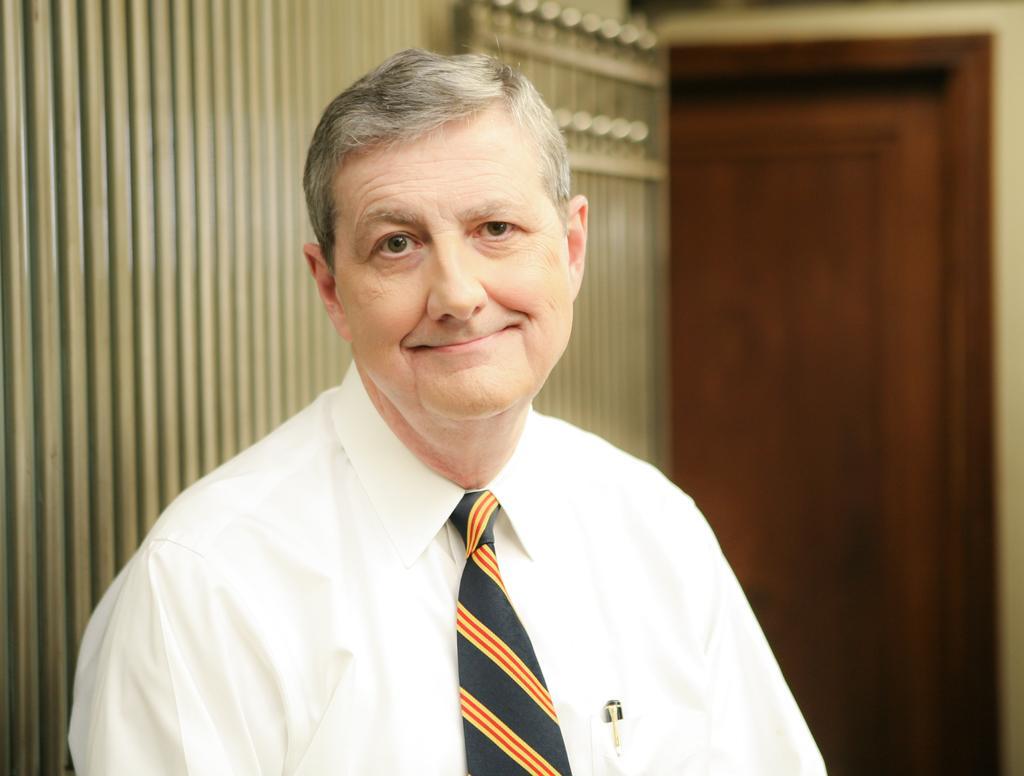How would you summarize this image in a sentence or two? In this image I can see a man is looking at his side, he wore tie, shirt. On the right side there is the door. 